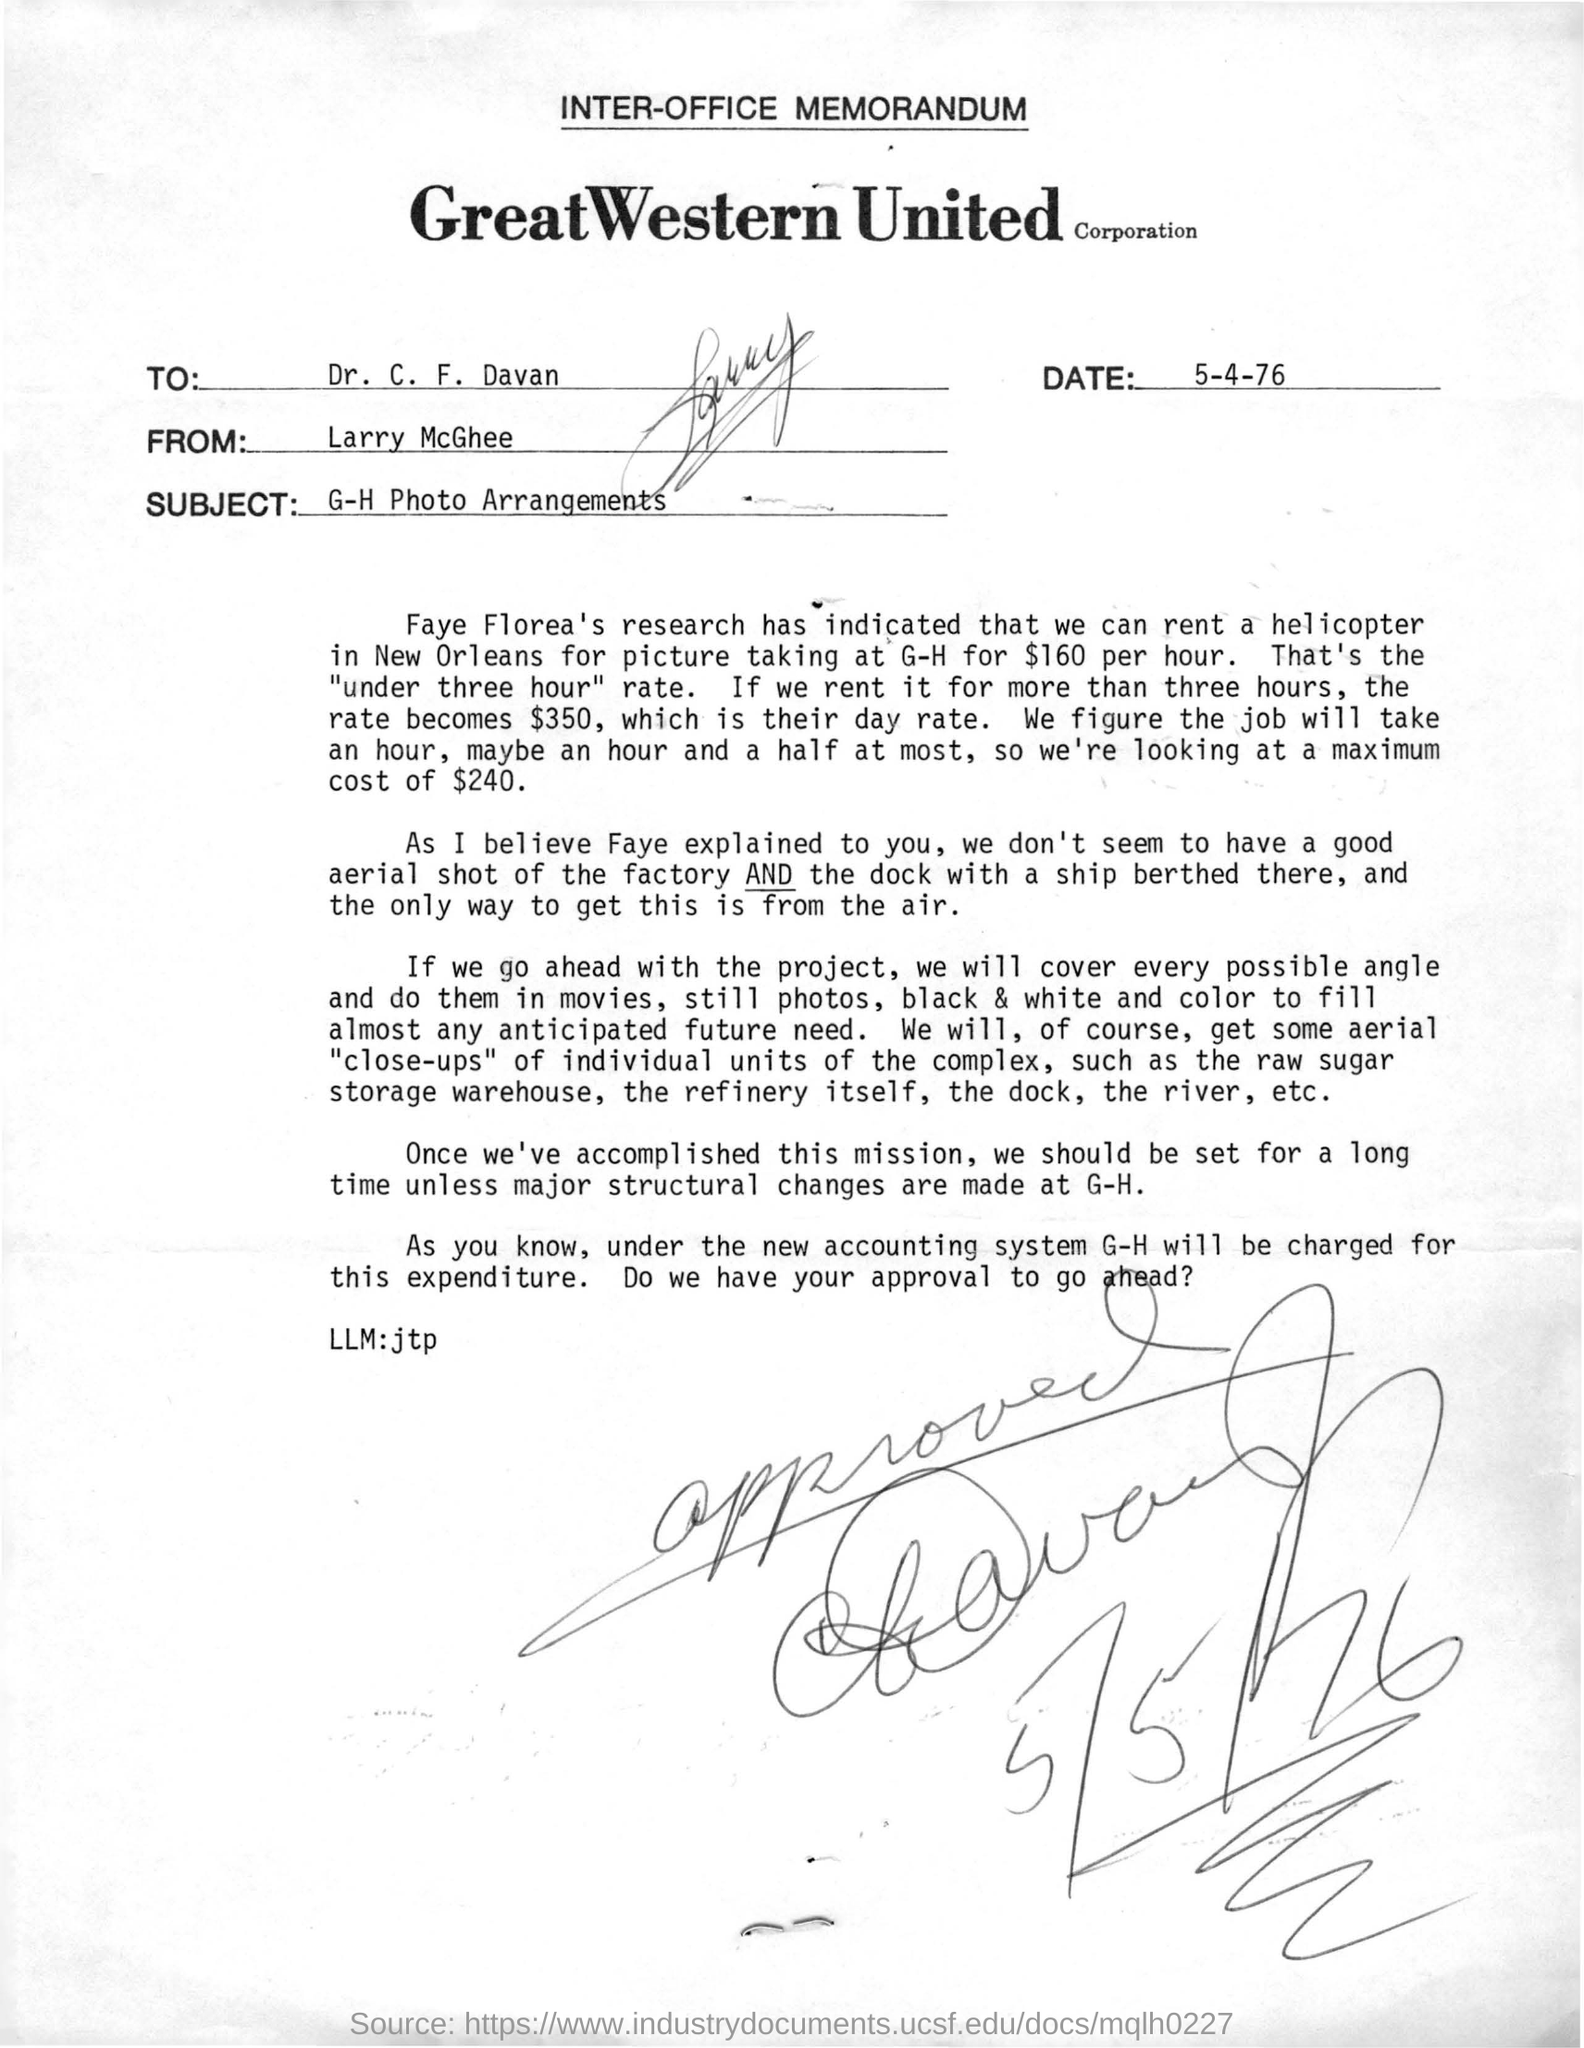Indicate a few pertinent items in this graphic. The memorandum was dated on May 4, 1976. This memorandum is addressed to Dr. C. F. Davan. The memorandum mentions a place where a helicopter can be rented, and that place is New Orleans. The memorandum is from Larry McGhee. 